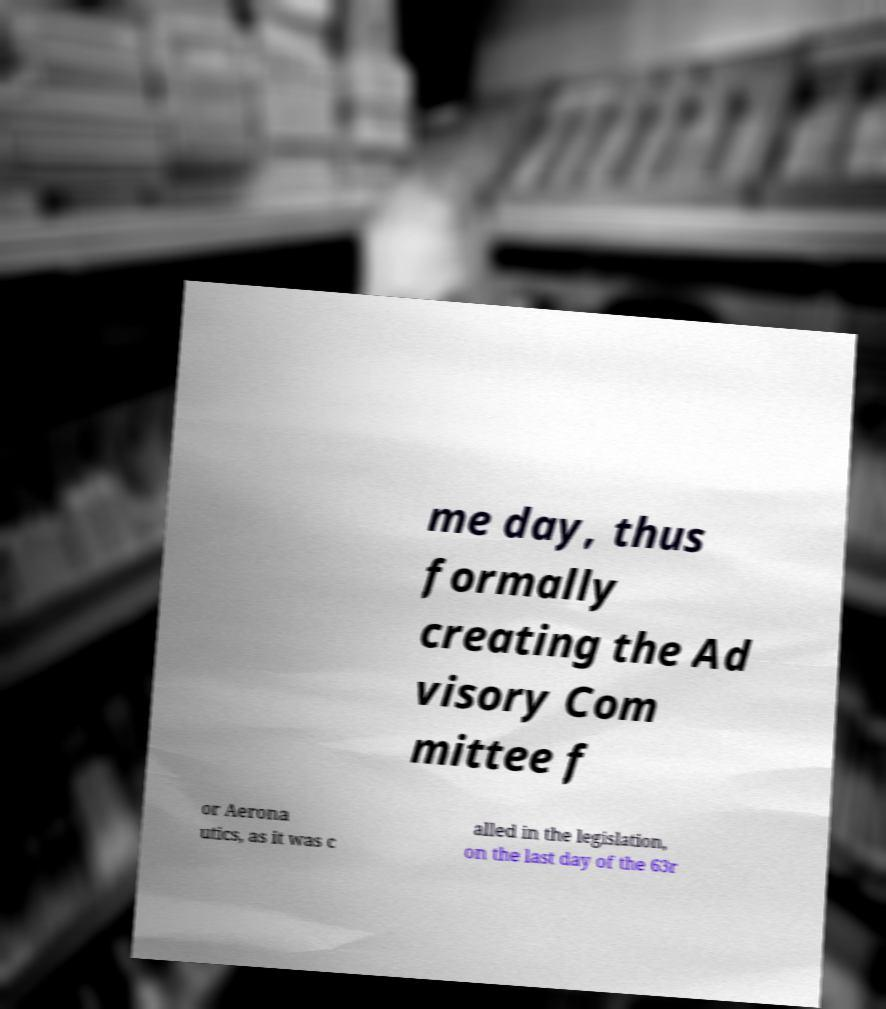There's text embedded in this image that I need extracted. Can you transcribe it verbatim? me day, thus formally creating the Ad visory Com mittee f or Aerona utics, as it was c alled in the legislation, on the last day of the 63r 